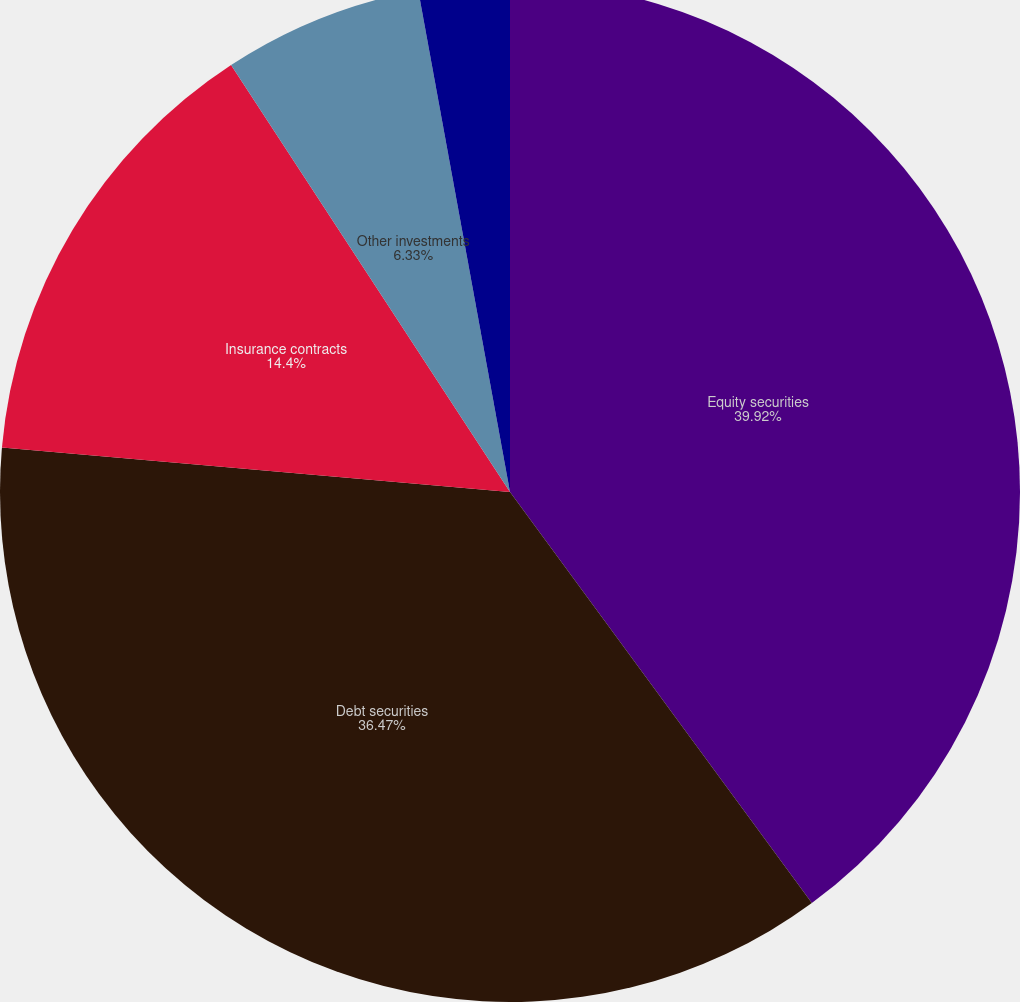Convert chart to OTSL. <chart><loc_0><loc_0><loc_500><loc_500><pie_chart><fcel>Equity securities<fcel>Debt securities<fcel>Insurance contracts<fcel>Other investments<fcel>Cash<nl><fcel>39.92%<fcel>36.47%<fcel>14.4%<fcel>6.33%<fcel>2.88%<nl></chart> 